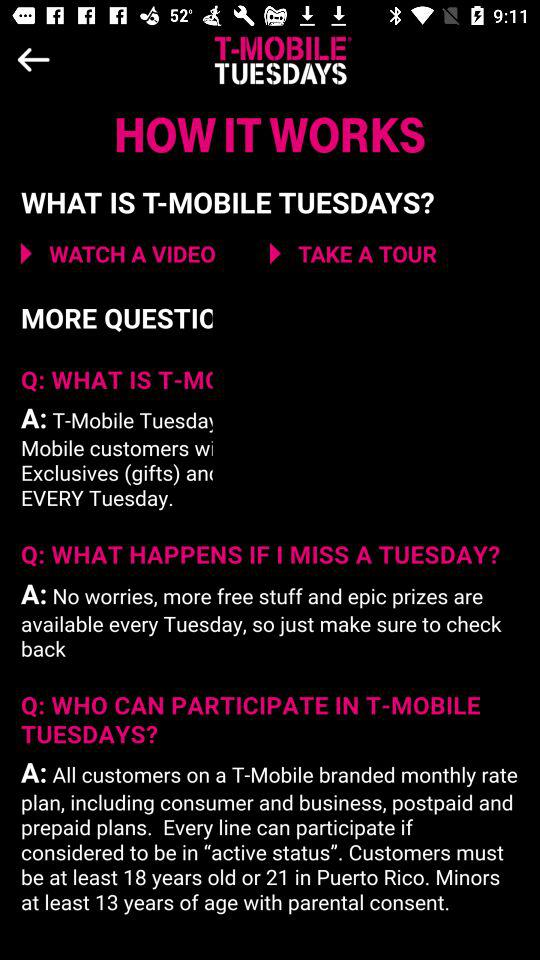What is the application name? The application name is "T-MOBILE TUESDAYS". 